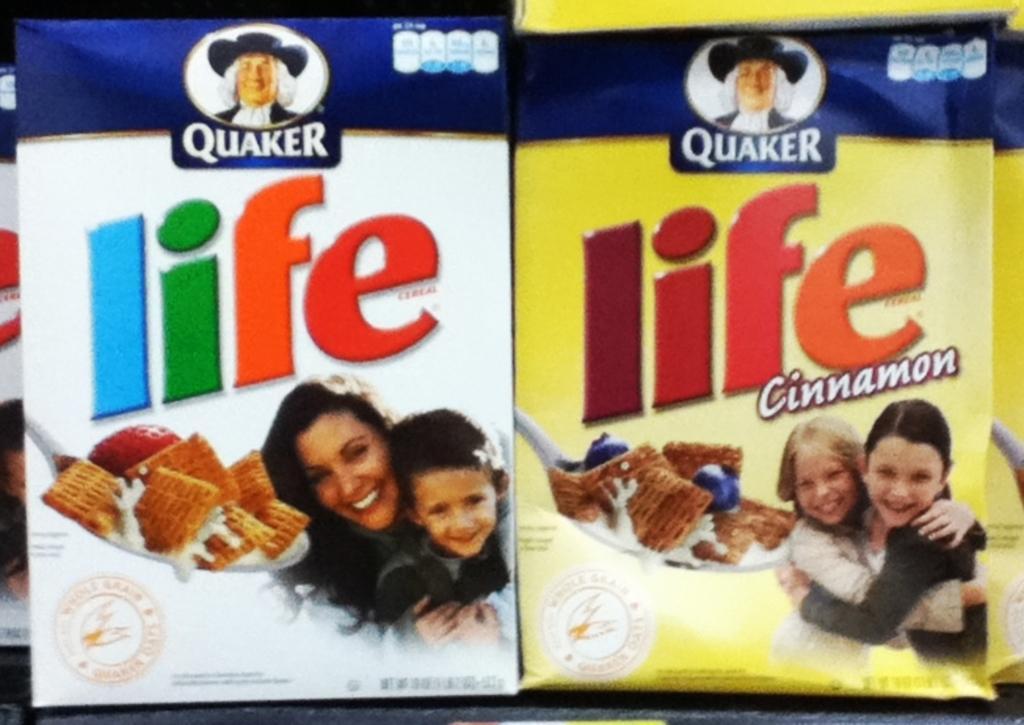Could you give a brief overview of what you see in this image? In this image, we can see some packets. 